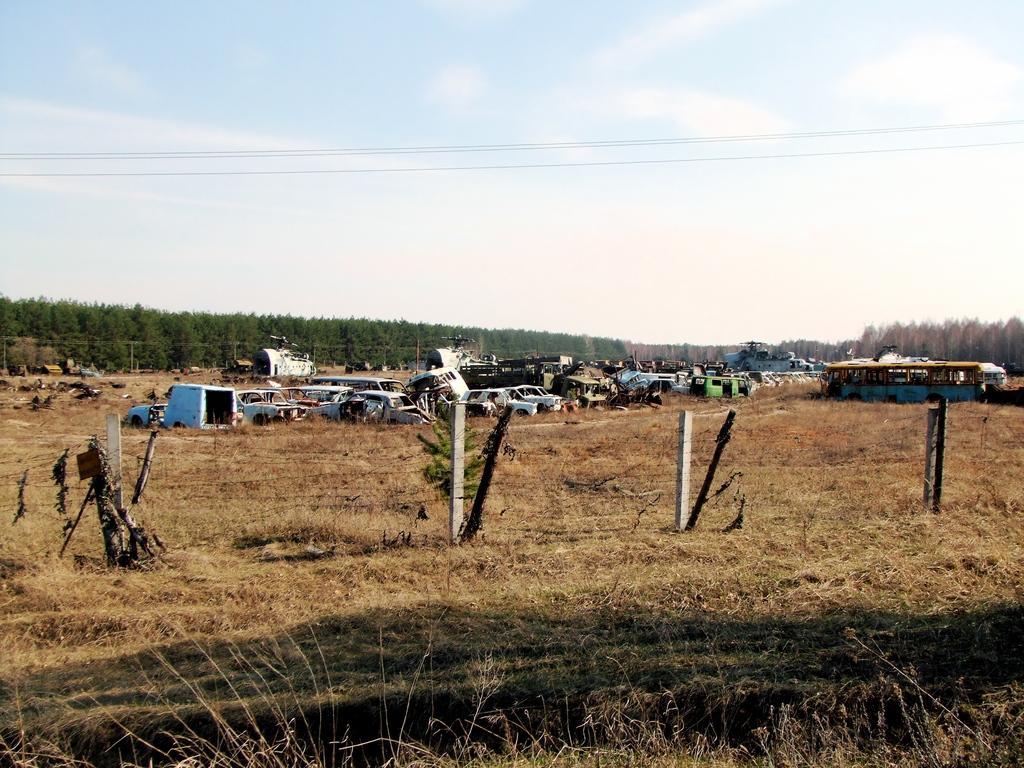Can you describe this image briefly? In this image I can see the ground, some grass on the ground which is brown in color, few white colored poles and few damaged vehicles on the ground. In the background I can see few trees which are green in color and the sky. 